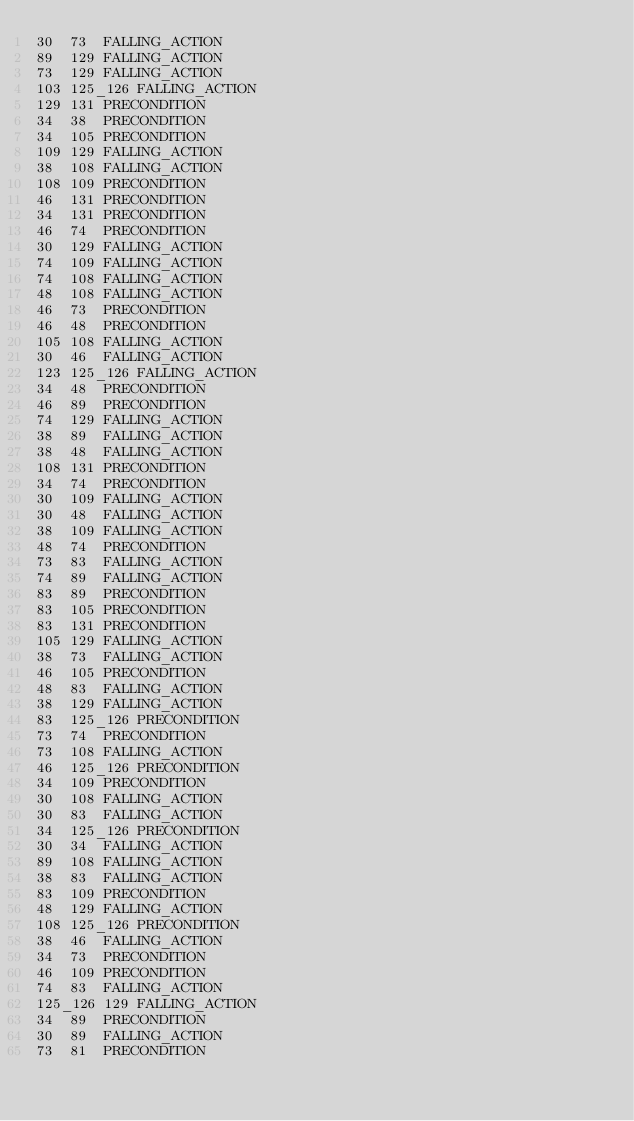<code> <loc_0><loc_0><loc_500><loc_500><_SQL_>30	73	FALLING_ACTION
89	129	FALLING_ACTION
73	129	FALLING_ACTION
103	125_126	FALLING_ACTION
129	131	PRECONDITION
34	38	PRECONDITION
34	105	PRECONDITION
109	129	FALLING_ACTION
38	108	FALLING_ACTION
108	109	PRECONDITION
46	131	PRECONDITION
34	131	PRECONDITION
46	74	PRECONDITION
30	129	FALLING_ACTION
74	109	FALLING_ACTION
74	108	FALLING_ACTION
48	108	FALLING_ACTION
46	73	PRECONDITION
46	48	PRECONDITION
105	108	FALLING_ACTION
30	46	FALLING_ACTION
123	125_126	FALLING_ACTION
34	48	PRECONDITION
46	89	PRECONDITION
74	129	FALLING_ACTION
38	89	FALLING_ACTION
38	48	FALLING_ACTION
108	131	PRECONDITION
34	74	PRECONDITION
30	109	FALLING_ACTION
30	48	FALLING_ACTION
38	109	FALLING_ACTION
48	74	PRECONDITION
73	83	FALLING_ACTION
74	89	FALLING_ACTION
83	89	PRECONDITION
83	105	PRECONDITION
83	131	PRECONDITION
105	129	FALLING_ACTION
38	73	FALLING_ACTION
46	105	PRECONDITION
48	83	FALLING_ACTION
38	129	FALLING_ACTION
83	125_126	PRECONDITION
73	74	PRECONDITION
73	108	FALLING_ACTION
46	125_126	PRECONDITION
34	109	PRECONDITION
30	108	FALLING_ACTION
30	83	FALLING_ACTION
34	125_126	PRECONDITION
30	34	FALLING_ACTION
89	108	FALLING_ACTION
38	83	FALLING_ACTION
83	109	PRECONDITION
48	129	FALLING_ACTION
108	125_126	PRECONDITION
38	46	FALLING_ACTION
34	73	PRECONDITION
46	109	PRECONDITION
74	83	FALLING_ACTION
125_126	129	FALLING_ACTION
34	89	PRECONDITION
30	89	FALLING_ACTION
73	81	PRECONDITION</code> 